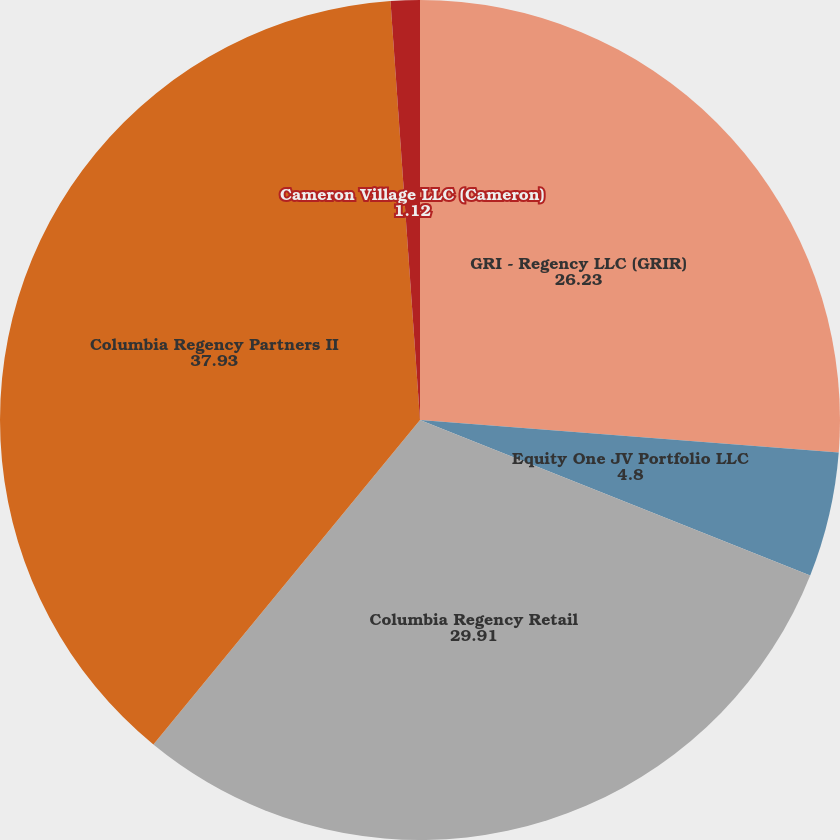Convert chart to OTSL. <chart><loc_0><loc_0><loc_500><loc_500><pie_chart><fcel>GRI - Regency LLC (GRIR)<fcel>Equity One JV Portfolio LLC<fcel>Columbia Regency Retail<fcel>Columbia Regency Partners II<fcel>Cameron Village LLC (Cameron)<nl><fcel>26.23%<fcel>4.8%<fcel>29.91%<fcel>37.93%<fcel>1.12%<nl></chart> 